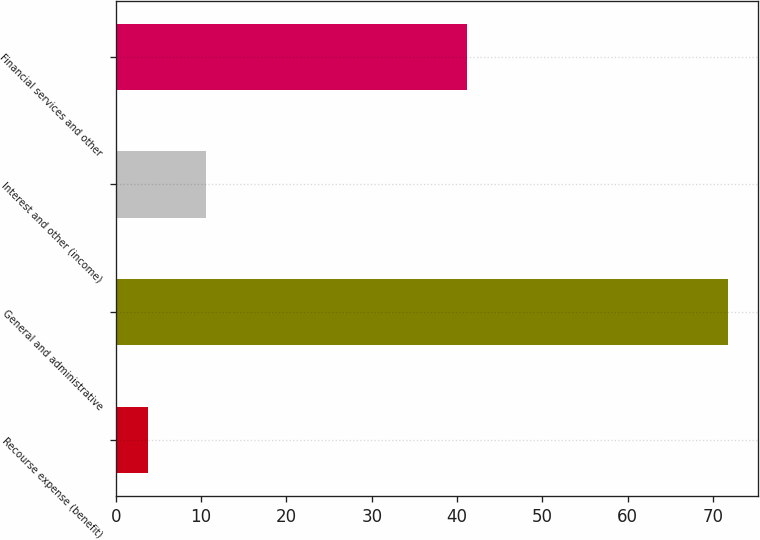Convert chart. <chart><loc_0><loc_0><loc_500><loc_500><bar_chart><fcel>Recourse expense (benefit)<fcel>General and administrative<fcel>Interest and other (income)<fcel>Financial services and other<nl><fcel>3.8<fcel>71.7<fcel>10.59<fcel>41.2<nl></chart> 